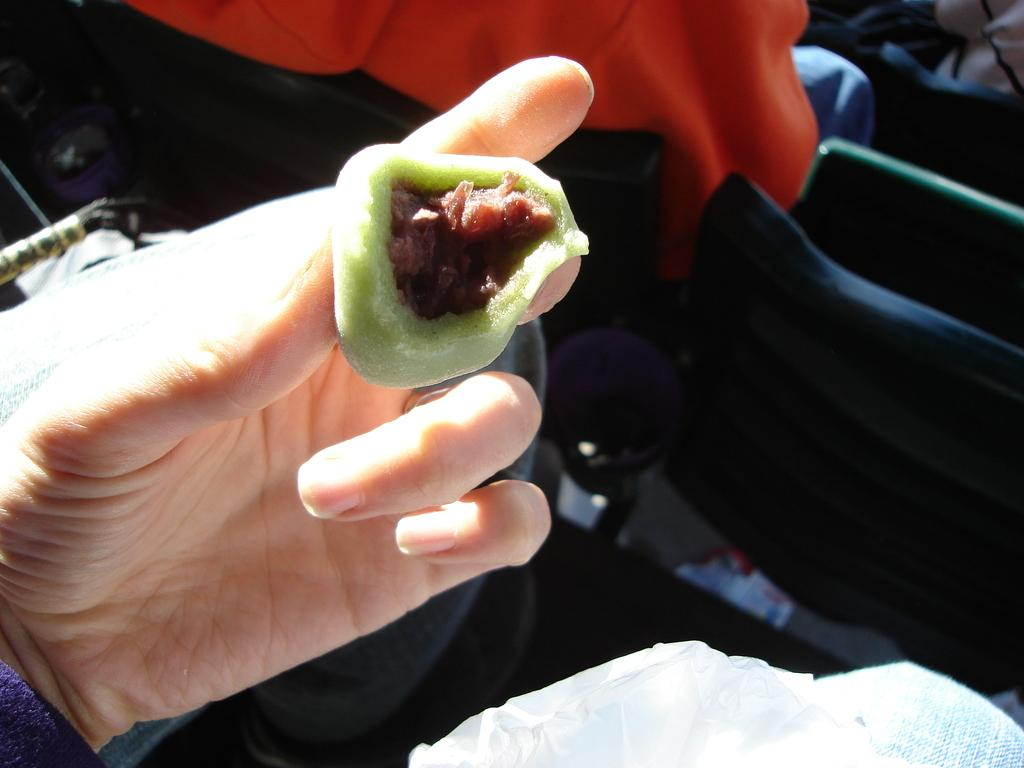What is the human hand holding in the image? The human hand is holding a food item in the image. Can you describe any other objects or furniture in the image? Yes, there is a chair in the image. What type of crown is the person wearing while holding the food item? There is no crown present in the image, and the person is not wearing one. 